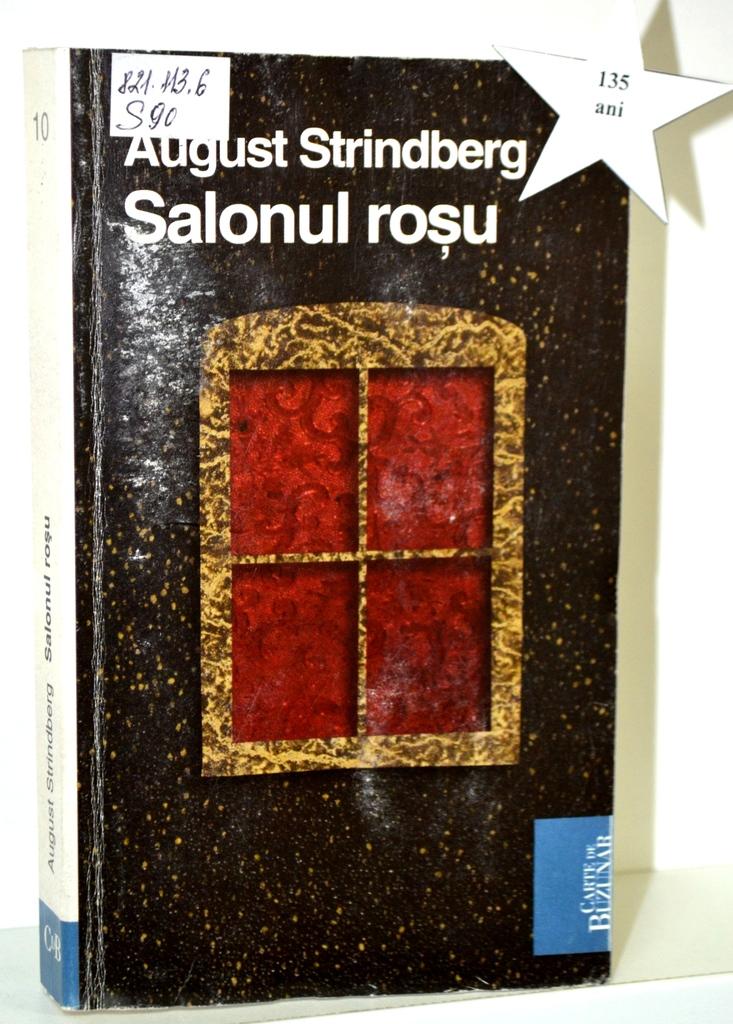Who is the author of salonul rosu?
Offer a terse response. August strindberg. What is the call number for the book?
Provide a succinct answer. 135. 